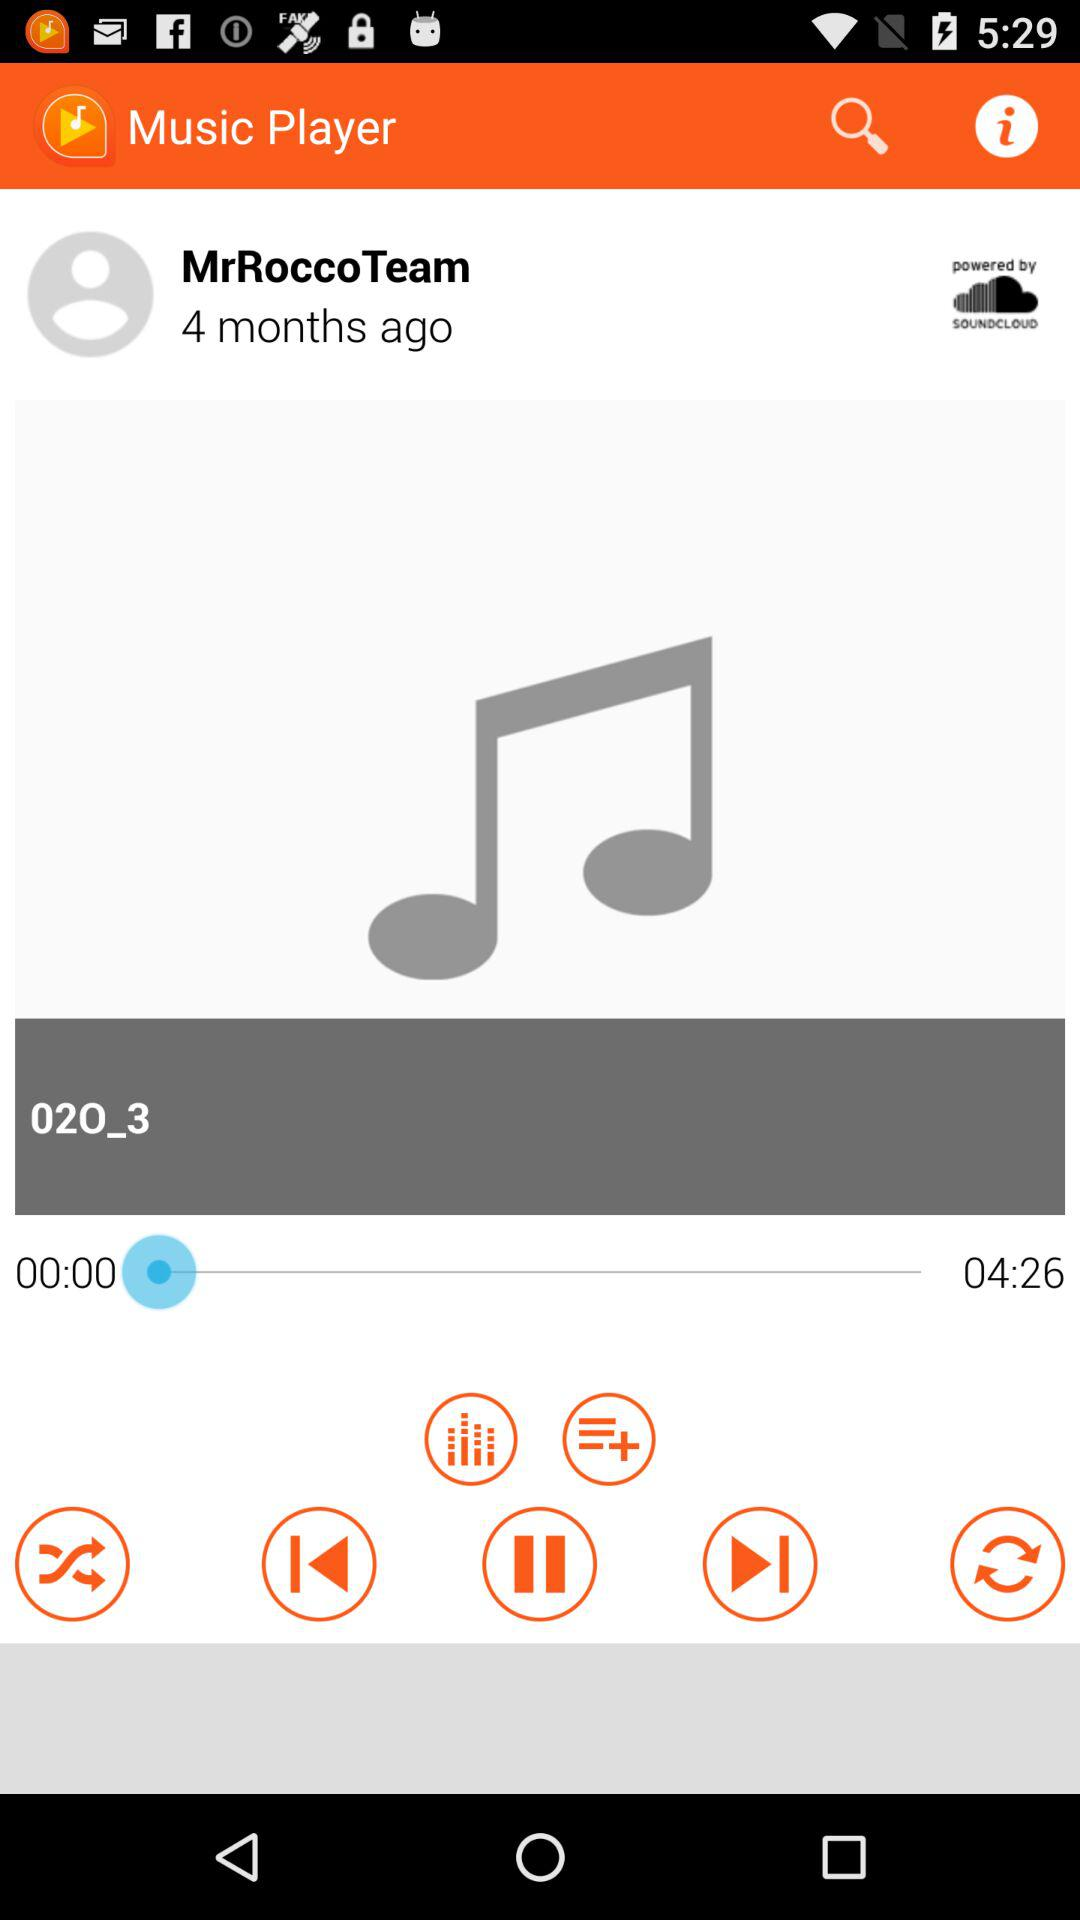Name the singer of a song which is currently playing?
When the provided information is insufficient, respond with <no answer>. <no answer> 